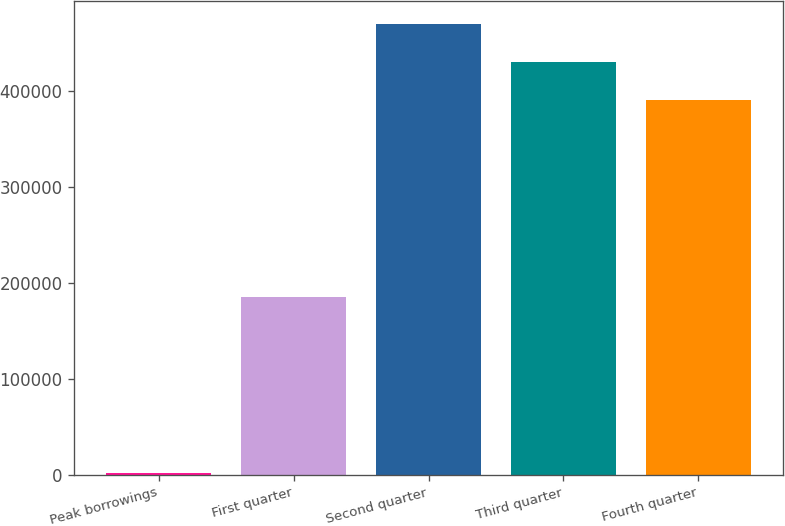<chart> <loc_0><loc_0><loc_500><loc_500><bar_chart><fcel>Peak borrowings<fcel>First quarter<fcel>Second quarter<fcel>Third quarter<fcel>Fourth quarter<nl><fcel>2015<fcel>185000<fcel>469597<fcel>429798<fcel>390000<nl></chart> 